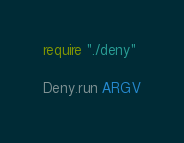Convert code to text. <code><loc_0><loc_0><loc_500><loc_500><_Crystal_>require "./deny"

Deny.run ARGV</code> 